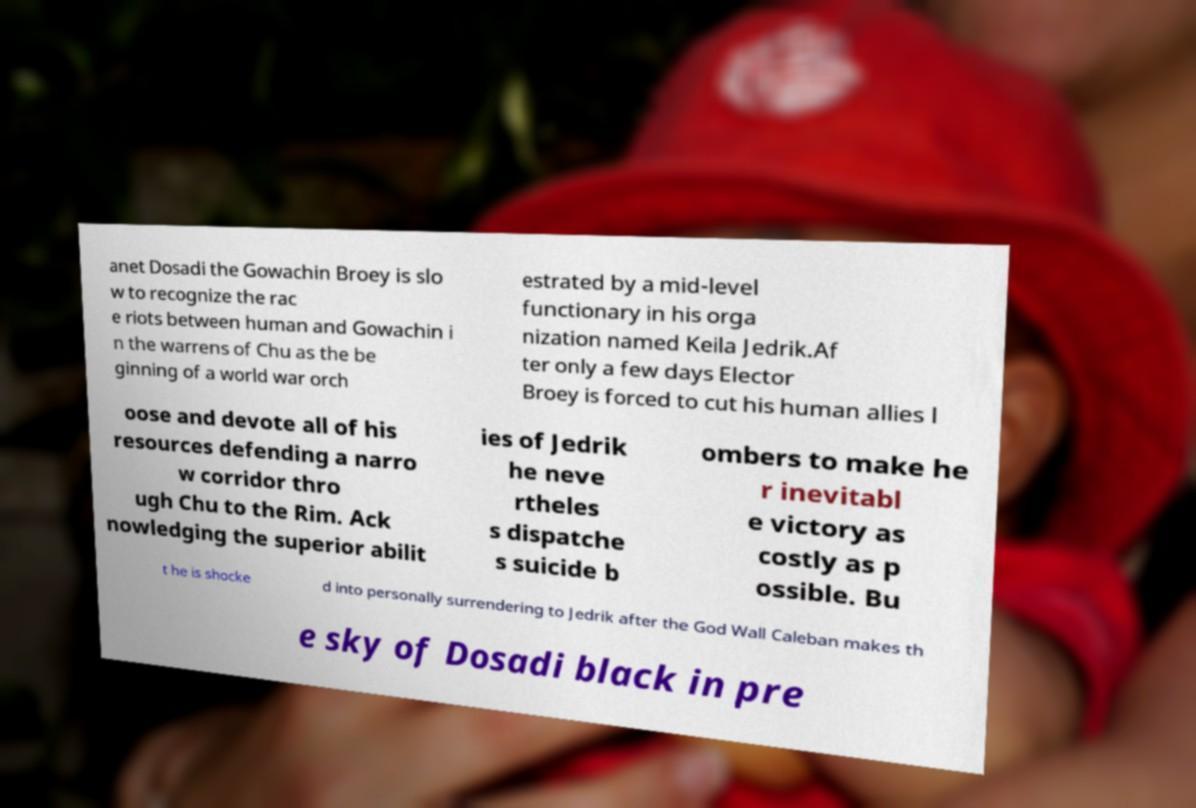For documentation purposes, I need the text within this image transcribed. Could you provide that? anet Dosadi the Gowachin Broey is slo w to recognize the rac e riots between human and Gowachin i n the warrens of Chu as the be ginning of a world war orch estrated by a mid-level functionary in his orga nization named Keila Jedrik.Af ter only a few days Elector Broey is forced to cut his human allies l oose and devote all of his resources defending a narro w corridor thro ugh Chu to the Rim. Ack nowledging the superior abilit ies of Jedrik he neve rtheles s dispatche s suicide b ombers to make he r inevitabl e victory as costly as p ossible. Bu t he is shocke d into personally surrendering to Jedrik after the God Wall Caleban makes th e sky of Dosadi black in pre 